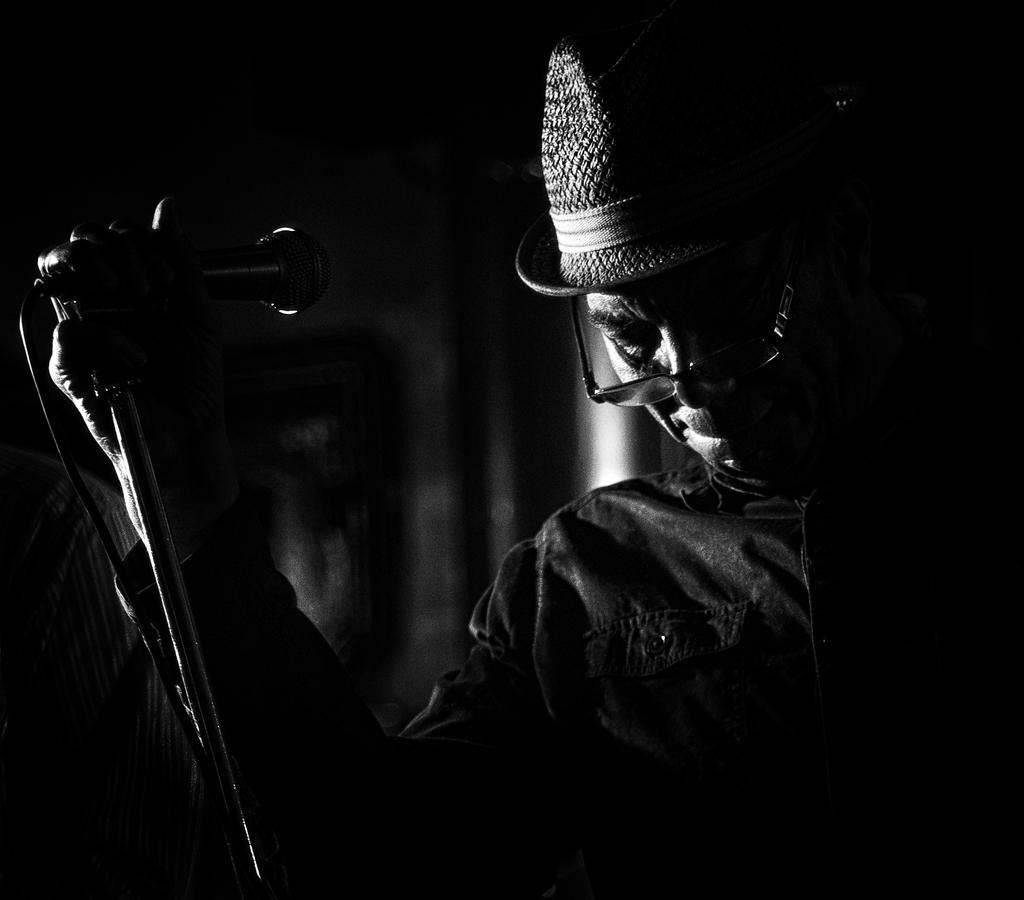What is the color scheme of the image? The image is black and white. Can you describe the person in the image? The person in the image is wearing a hat and spectacles. What is the person holding in the image? The person is holding a microphone. What can be observed about the background of the image? The background of the image is dark. What type of vacation destination is depicted in the image? There is no vacation destination present in the image; it features a person holding a microphone. Can you tell me how many tickets are visible in the image? There are no tickets present in the image. 